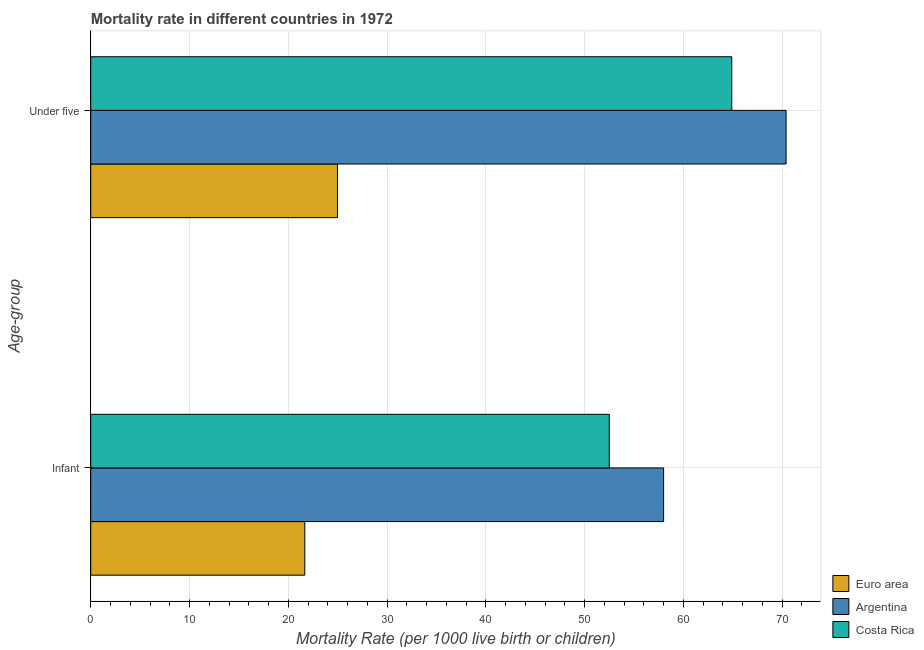How many groups of bars are there?
Make the answer very short. 2. Are the number of bars per tick equal to the number of legend labels?
Make the answer very short. Yes. Are the number of bars on each tick of the Y-axis equal?
Your answer should be very brief. Yes. How many bars are there on the 2nd tick from the bottom?
Offer a terse response. 3. What is the label of the 1st group of bars from the top?
Your answer should be compact. Under five. What is the under-5 mortality rate in Argentina?
Provide a succinct answer. 70.4. Across all countries, what is the maximum under-5 mortality rate?
Give a very brief answer. 70.4. Across all countries, what is the minimum infant mortality rate?
Offer a terse response. 21.67. What is the total infant mortality rate in the graph?
Offer a terse response. 132.17. What is the difference between the under-5 mortality rate in Costa Rica and that in Euro area?
Your response must be concise. 39.92. What is the difference between the under-5 mortality rate in Argentina and the infant mortality rate in Euro area?
Provide a succinct answer. 48.73. What is the average infant mortality rate per country?
Offer a very short reply. 44.06. What is the difference between the infant mortality rate and under-5 mortality rate in Costa Rica?
Offer a terse response. -12.4. In how many countries, is the infant mortality rate greater than 48 ?
Your answer should be compact. 2. What is the ratio of the under-5 mortality rate in Costa Rica to that in Euro area?
Offer a terse response. 2.6. Is the under-5 mortality rate in Costa Rica less than that in Euro area?
Provide a succinct answer. No. In how many countries, is the under-5 mortality rate greater than the average under-5 mortality rate taken over all countries?
Give a very brief answer. 2. What does the 1st bar from the top in Infant represents?
Provide a short and direct response. Costa Rica. What does the 2nd bar from the bottom in Infant represents?
Your response must be concise. Argentina. How many countries are there in the graph?
Provide a short and direct response. 3. What is the difference between two consecutive major ticks on the X-axis?
Offer a terse response. 10. Where does the legend appear in the graph?
Give a very brief answer. Bottom right. How many legend labels are there?
Give a very brief answer. 3. What is the title of the graph?
Provide a short and direct response. Mortality rate in different countries in 1972. What is the label or title of the X-axis?
Your answer should be very brief. Mortality Rate (per 1000 live birth or children). What is the label or title of the Y-axis?
Give a very brief answer. Age-group. What is the Mortality Rate (per 1000 live birth or children) of Euro area in Infant?
Keep it short and to the point. 21.67. What is the Mortality Rate (per 1000 live birth or children) in Argentina in Infant?
Give a very brief answer. 58. What is the Mortality Rate (per 1000 live birth or children) in Costa Rica in Infant?
Offer a terse response. 52.5. What is the Mortality Rate (per 1000 live birth or children) of Euro area in Under five?
Your answer should be very brief. 24.98. What is the Mortality Rate (per 1000 live birth or children) in Argentina in Under five?
Make the answer very short. 70.4. What is the Mortality Rate (per 1000 live birth or children) in Costa Rica in Under five?
Your response must be concise. 64.9. Across all Age-group, what is the maximum Mortality Rate (per 1000 live birth or children) in Euro area?
Provide a short and direct response. 24.98. Across all Age-group, what is the maximum Mortality Rate (per 1000 live birth or children) in Argentina?
Your answer should be compact. 70.4. Across all Age-group, what is the maximum Mortality Rate (per 1000 live birth or children) of Costa Rica?
Provide a short and direct response. 64.9. Across all Age-group, what is the minimum Mortality Rate (per 1000 live birth or children) in Euro area?
Offer a very short reply. 21.67. Across all Age-group, what is the minimum Mortality Rate (per 1000 live birth or children) in Argentina?
Offer a very short reply. 58. Across all Age-group, what is the minimum Mortality Rate (per 1000 live birth or children) in Costa Rica?
Your answer should be compact. 52.5. What is the total Mortality Rate (per 1000 live birth or children) of Euro area in the graph?
Ensure brevity in your answer.  46.65. What is the total Mortality Rate (per 1000 live birth or children) in Argentina in the graph?
Provide a succinct answer. 128.4. What is the total Mortality Rate (per 1000 live birth or children) of Costa Rica in the graph?
Ensure brevity in your answer.  117.4. What is the difference between the Mortality Rate (per 1000 live birth or children) in Euro area in Infant and that in Under five?
Offer a very short reply. -3.31. What is the difference between the Mortality Rate (per 1000 live birth or children) of Costa Rica in Infant and that in Under five?
Your response must be concise. -12.4. What is the difference between the Mortality Rate (per 1000 live birth or children) in Euro area in Infant and the Mortality Rate (per 1000 live birth or children) in Argentina in Under five?
Your answer should be very brief. -48.73. What is the difference between the Mortality Rate (per 1000 live birth or children) in Euro area in Infant and the Mortality Rate (per 1000 live birth or children) in Costa Rica in Under five?
Make the answer very short. -43.23. What is the average Mortality Rate (per 1000 live birth or children) of Euro area per Age-group?
Offer a terse response. 23.32. What is the average Mortality Rate (per 1000 live birth or children) in Argentina per Age-group?
Offer a terse response. 64.2. What is the average Mortality Rate (per 1000 live birth or children) in Costa Rica per Age-group?
Keep it short and to the point. 58.7. What is the difference between the Mortality Rate (per 1000 live birth or children) in Euro area and Mortality Rate (per 1000 live birth or children) in Argentina in Infant?
Ensure brevity in your answer.  -36.33. What is the difference between the Mortality Rate (per 1000 live birth or children) in Euro area and Mortality Rate (per 1000 live birth or children) in Costa Rica in Infant?
Offer a very short reply. -30.83. What is the difference between the Mortality Rate (per 1000 live birth or children) in Euro area and Mortality Rate (per 1000 live birth or children) in Argentina in Under five?
Keep it short and to the point. -45.42. What is the difference between the Mortality Rate (per 1000 live birth or children) in Euro area and Mortality Rate (per 1000 live birth or children) in Costa Rica in Under five?
Offer a very short reply. -39.92. What is the difference between the Mortality Rate (per 1000 live birth or children) of Argentina and Mortality Rate (per 1000 live birth or children) of Costa Rica in Under five?
Make the answer very short. 5.5. What is the ratio of the Mortality Rate (per 1000 live birth or children) of Euro area in Infant to that in Under five?
Give a very brief answer. 0.87. What is the ratio of the Mortality Rate (per 1000 live birth or children) of Argentina in Infant to that in Under five?
Your answer should be very brief. 0.82. What is the ratio of the Mortality Rate (per 1000 live birth or children) of Costa Rica in Infant to that in Under five?
Offer a very short reply. 0.81. What is the difference between the highest and the second highest Mortality Rate (per 1000 live birth or children) in Euro area?
Provide a succinct answer. 3.31. What is the difference between the highest and the lowest Mortality Rate (per 1000 live birth or children) of Euro area?
Offer a terse response. 3.31. What is the difference between the highest and the lowest Mortality Rate (per 1000 live birth or children) in Argentina?
Keep it short and to the point. 12.4. What is the difference between the highest and the lowest Mortality Rate (per 1000 live birth or children) in Costa Rica?
Give a very brief answer. 12.4. 